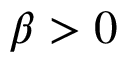Convert formula to latex. <formula><loc_0><loc_0><loc_500><loc_500>\beta > 0</formula> 